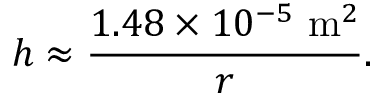Convert formula to latex. <formula><loc_0><loc_0><loc_500><loc_500>h \approx { \frac { 1 . 4 8 \times 1 0 ^ { - 5 } \ { m } ^ { 2 } } { r } } .</formula> 